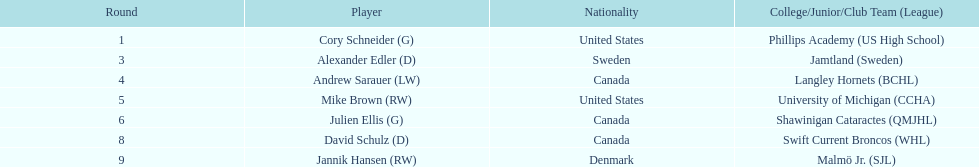List each player drafted from canada. Andrew Sarauer (LW), Julien Ellis (G), David Schulz (D). 